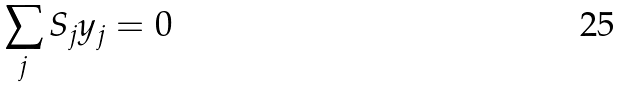Convert formula to latex. <formula><loc_0><loc_0><loc_500><loc_500>\sum _ { j } S _ { j } y _ { j } = 0</formula> 